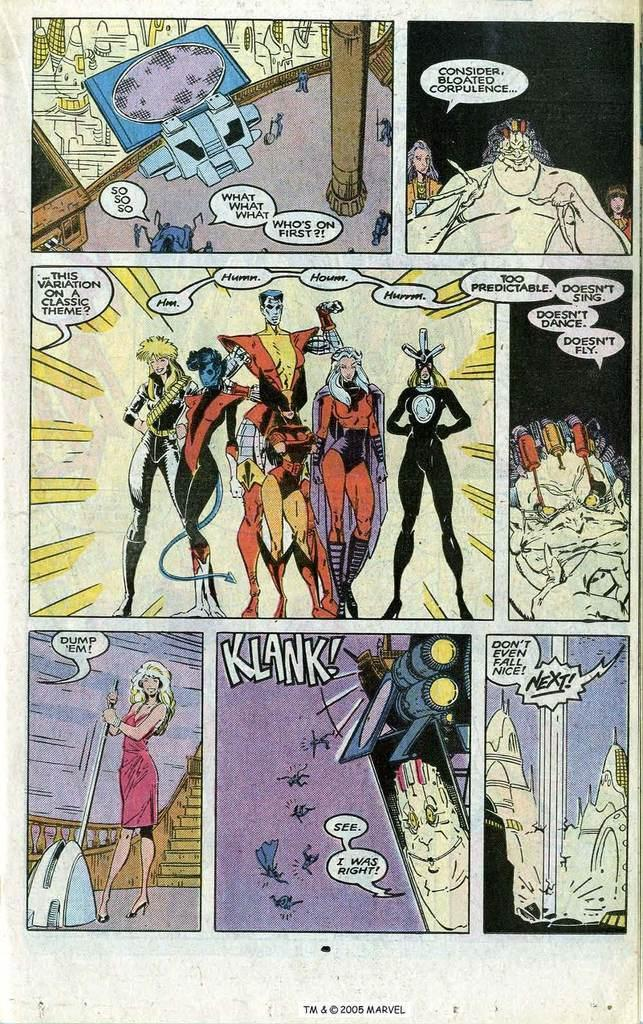What is present in the image that features multiple images? There is a poster in the image that has seven images. What type of images are on the poster? The images contain cartoons and text. What is the color of the background on the poster? The background of the poster is white. What type of nut is present on the tray in the image? There is no tray or nut present in the image; it features a poster with cartoon images and text. What time of day is depicted in the image? The image does not depict a specific time of day, as it only shows a poster with cartoon images and text. 